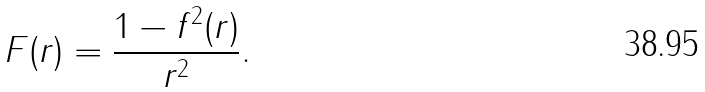Convert formula to latex. <formula><loc_0><loc_0><loc_500><loc_500>F ( r ) = \frac { 1 - f ^ { 2 } ( r ) } { r ^ { 2 } } .</formula> 